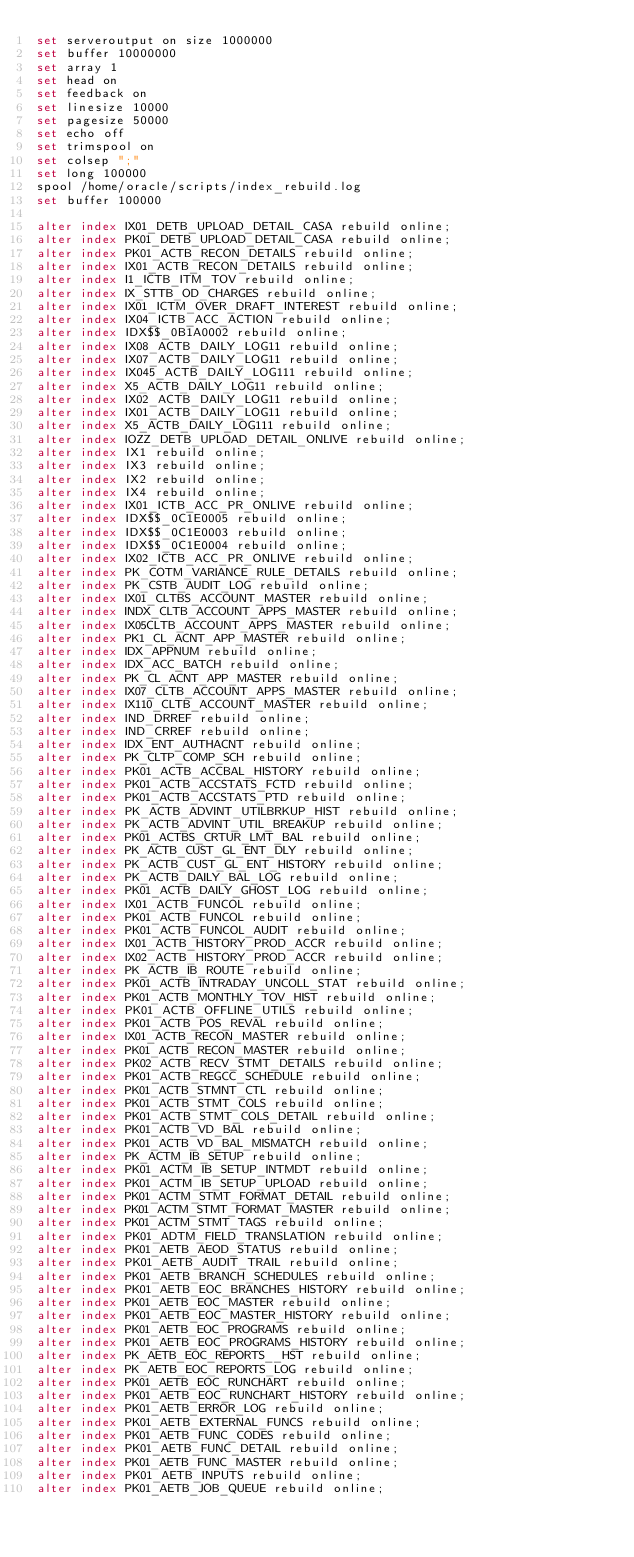Convert code to text. <code><loc_0><loc_0><loc_500><loc_500><_SQL_>set serveroutput on size 1000000
set buffer 10000000
set array 1
set head on
set feedback on
set linesize 10000
set pagesize 50000
set echo off
set trimspool on
set colsep ";"
set long 100000
spool /home/oracle/scripts/index_rebuild.log
set buffer 100000

alter index IX01_DETB_UPLOAD_DETAIL_CASA rebuild online;
alter index PK01_DETB_UPLOAD_DETAIL_CASA rebuild online;
alter index PK01_ACTB_RECON_DETAILS rebuild online;
alter index IX01_ACTB_RECON_DETAILS rebuild online;
alter index I1_ICTB_ITM_TOV rebuild online;
alter index IX_STTB_OD_CHARGES rebuild online;
alter index IX01_ICTM_OVER_DRAFT_INTEREST rebuild online;
alter index IX04_ICTB_ACC_ACTION rebuild online;
alter index IDX$$_0B1A0002 rebuild online;
alter index IX08_ACTB_DAILY_LOG11 rebuild online;
alter index IX07_ACTB_DAILY_LOG11 rebuild online;
alter index IX045_ACTB_DAILY_LOG111 rebuild online;
alter index X5_ACTB_DAILY_LOG11 rebuild online;
alter index IX02_ACTB_DAILY_LOG11 rebuild online;
alter index IX01_ACTB_DAILY_LOG11 rebuild online;
alter index X5_ACTB_DAILY_LOG111 rebuild online;
alter index IOZZ_DETB_UPLOAD_DETAIL_ONLIVE rebuild online;
alter index IX1 rebuild online;
alter index IX3 rebuild online;
alter index IX2 rebuild online;
alter index IX4 rebuild online;
alter index IX01_ICTB_ACC_PR_ONLIVE rebuild online;
alter index IDX$$_0C1E0005 rebuild online;
alter index IDX$$_0C1E0003 rebuild online;
alter index IDX$$_0C1E0004 rebuild online;
alter index IX02_ICTB_ACC_PR_ONLIVE rebuild online;
alter index PK_COTM_VARIANCE_RULE_DETAILS rebuild online;
alter index PK_CSTB_AUDIT_LOG rebuild online;
alter index IX01_CLTBS_ACCOUNT_MASTER rebuild online;
alter index INDX_CLTB_ACCOUNT_APPS_MASTER rebuild online;
alter index IX05CLTB_ACCOUNT_APPS_MASTER rebuild online;
alter index PK1_CL_ACNT_APP_MASTER rebuild online;
alter index IDX_APPNUM rebuild online;
alter index IDX_ACC_BATCH rebuild online;
alter index PK_CL_ACNT_APP_MASTER rebuild online;
alter index IX07_CLTB_ACCOUNT_APPS_MASTER rebuild online;
alter index IX110_CLTB_ACCOUNT_MASTER rebuild online;
alter index IND_DRREF rebuild online;
alter index IND_CRREF rebuild online;
alter index IDX_ENT_AUTHACNT rebuild online;
alter index PK_CLTP_COMP_SCH rebuild online;
alter index PK01_ACTB_ACCBAL_HISTORY rebuild online;
alter index PK01_ACTB_ACCSTATS_FCTD rebuild online;
alter index PK01_ACTB_ACCSTATS_PTD rebuild online;
alter index PK_ACTB_ADVINT_UTILBRKUP_HIST rebuild online;
alter index PK_ACTB_ADVINT_UTIL_BREAKUP rebuild online;
alter index PK01_ACTBS_CRTUR_LMT_BAL rebuild online;
alter index PK_ACTB_CUST_GL_ENT_DLY rebuild online;
alter index PK_ACTB_CUST_GL_ENT_HISTORY rebuild online;
alter index PK_ACTB_DAILY_BAL_LOG rebuild online;
alter index PK01_ACTB_DAILY_GHOST_LOG rebuild online;
alter index IX01_ACTB_FUNCOL rebuild online;
alter index PK01_ACTB_FUNCOL rebuild online;
alter index PK01_ACTB_FUNCOL_AUDIT rebuild online;
alter index IX01_ACTB_HISTORY_PROD_ACCR rebuild online;
alter index IX02_ACTB_HISTORY_PROD_ACCR rebuild online;
alter index PK_ACTB_IB_ROUTE rebuild online;
alter index PK01_ACTB_INTRADAY_UNCOLL_STAT rebuild online;
alter index PK01_ACTB_MONTHLY_TOV_HIST rebuild online;
alter index PK01_ACTB_OFFLINE_UTILS rebuild online;
alter index PK01_ACTB_POS_REVAL rebuild online;
alter index IX01_ACTB_RECON_MASTER rebuild online;
alter index PK01_ACTB_RECON_MASTER rebuild online;
alter index PK02_ACTB_RECV_STMT_DETAILS rebuild online;
alter index PK01_ACTB_REGCC_SCHEDULE rebuild online;
alter index PK01_ACTB_STMNT_CTL rebuild online;
alter index PK01_ACTB_STMT_COLS rebuild online;
alter index PK01_ACTB_STMT_COLS_DETAIL rebuild online;
alter index PK01_ACTB_VD_BAL rebuild online;
alter index PK01_ACTB_VD_BAL_MISMATCH rebuild online;
alter index PK_ACTM_IB_SETUP rebuild online;
alter index PK01_ACTM_IB_SETUP_INTMDT rebuild online;
alter index PK01_ACTM_IB_SETUP_UPLOAD rebuild online;
alter index PK01_ACTM_STMT_FORMAT_DETAIL rebuild online;
alter index PK01_ACTM_STMT_FORMAT_MASTER rebuild online;
alter index PK01_ACTM_STMT_TAGS rebuild online;
alter index PK01_ADTM_FIELD_TRANSLATION rebuild online;
alter index PK01_AETB_AEOD_STATUS rebuild online;
alter index PK01_AETB_AUDIT_TRAIL rebuild online;
alter index PK01_AETB_BRANCH_SCHEDULES rebuild online;
alter index PK01_AETB_EOC_BRANCHES_HISTORY rebuild online;
alter index PK01_AETB_EOC_MASTER rebuild online;
alter index PK01_AETB_EOC_MASTER_HISTORY rebuild online;
alter index PK01_AETB_EOC_PROGRAMS rebuild online;
alter index PK01_AETB_EOC_PROGRAMS_HISTORY rebuild online;
alter index PK_AETB_EOC_REPORTS__HST rebuild online;
alter index PK_AETB_EOC_REPORTS_LOG rebuild online;
alter index PK01_AETB_EOC_RUNCHART rebuild online;
alter index PK01_AETB_EOC_RUNCHART_HISTORY rebuild online;
alter index PK01_AETB_ERROR_LOG rebuild online;
alter index PK01_AETB_EXTERNAL_FUNCS rebuild online;
alter index PK01_AETB_FUNC_CODES rebuild online;
alter index PK01_AETB_FUNC_DETAIL rebuild online;
alter index PK01_AETB_FUNC_MASTER rebuild online;
alter index PK01_AETB_INPUTS rebuild online;
alter index PK01_AETB_JOB_QUEUE rebuild online;</code> 